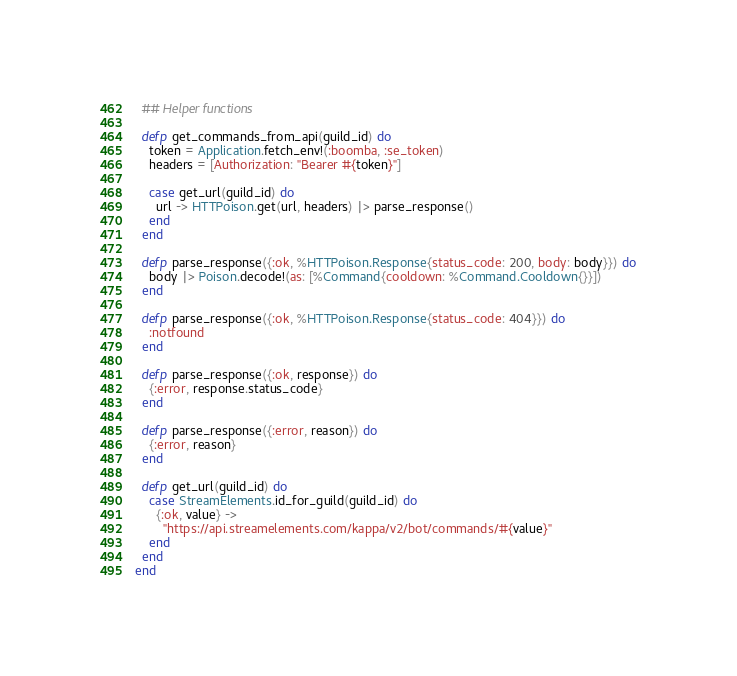Convert code to text. <code><loc_0><loc_0><loc_500><loc_500><_Elixir_>  ## Helper functions

  defp get_commands_from_api(guild_id) do
    token = Application.fetch_env!(:boomba, :se_token)
    headers = [Authorization: "Bearer #{token}"]

    case get_url(guild_id) do
      url -> HTTPoison.get(url, headers) |> parse_response()
    end
  end

  defp parse_response({:ok, %HTTPoison.Response{status_code: 200, body: body}}) do
    body |> Poison.decode!(as: [%Command{cooldown: %Command.Cooldown{}}])
  end

  defp parse_response({:ok, %HTTPoison.Response{status_code: 404}}) do
    :notfound
  end

  defp parse_response({:ok, response}) do
    {:error, response.status_code}
  end

  defp parse_response({:error, reason}) do
    {:error, reason}
  end

  defp get_url(guild_id) do
    case StreamElements.id_for_guild(guild_id) do
      {:ok, value} ->
        "https://api.streamelements.com/kappa/v2/bot/commands/#{value}"
    end
  end
end
</code> 